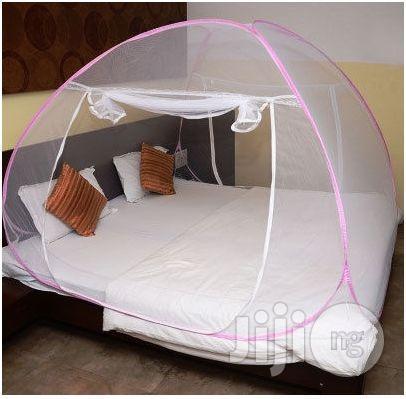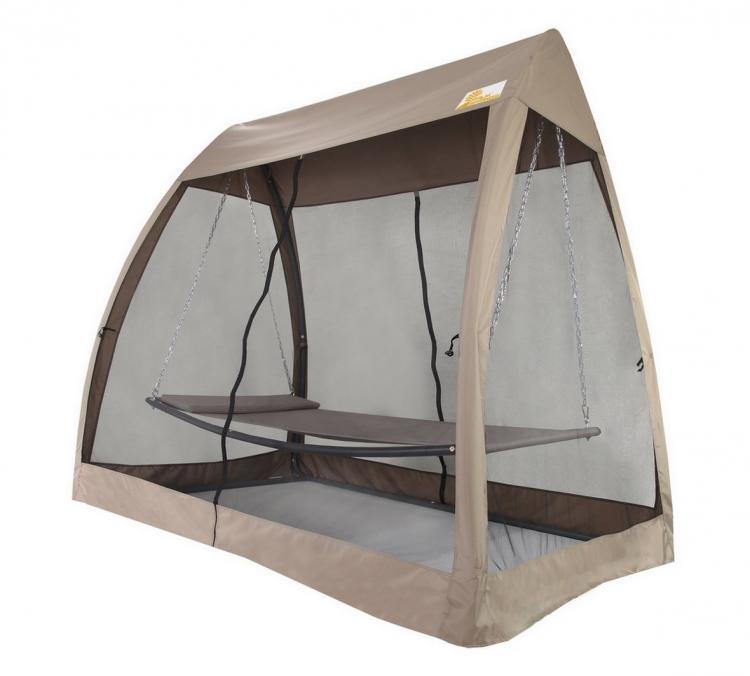The first image is the image on the left, the second image is the image on the right. Evaluate the accuracy of this statement regarding the images: "A canopy screen is sitting on bare grass with nothing under it.". Is it true? Answer yes or no. No. The first image is the image on the left, the second image is the image on the right. Considering the images on both sides, is "there are two white pillows in the image on the left" valid? Answer yes or no. Yes. 